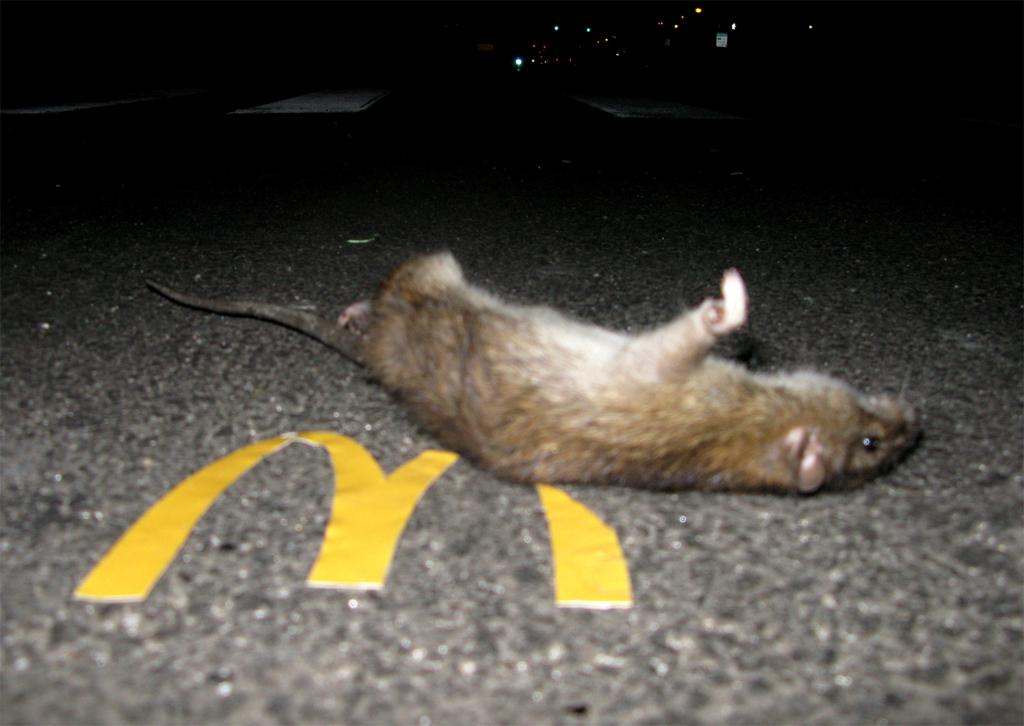What animal is on the road in the image? There is a rat on the road in the image. What can be seen in the image besides the rat? Lights are visible in the image. How would you describe the overall lighting in the image? The background of the image is dark. What type of farm animals can be seen in the image? There are no farm animals present in the image; it features a rat on the road and lights in the background. 